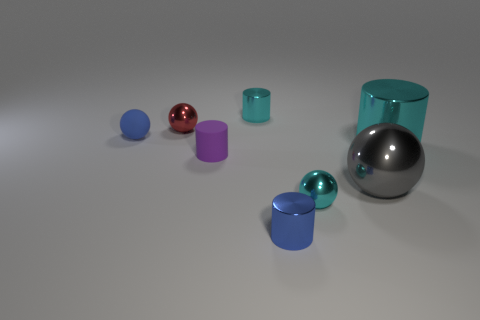Add 1 small cyan metallic balls. How many objects exist? 9 Add 7 small metal cylinders. How many small metal cylinders are left? 9 Add 6 red metal objects. How many red metal objects exist? 7 Subtract 1 red spheres. How many objects are left? 7 Subtract all large spheres. Subtract all tiny shiny cylinders. How many objects are left? 5 